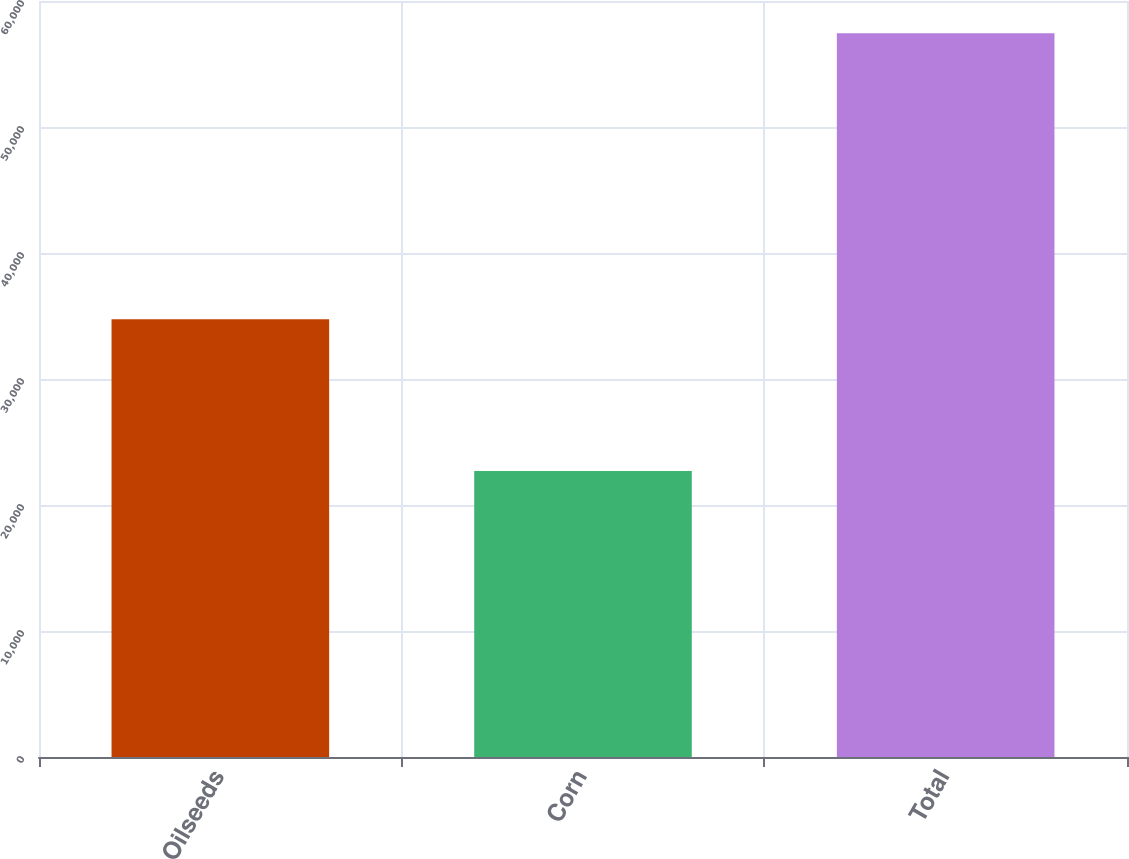<chart> <loc_0><loc_0><loc_500><loc_500><bar_chart><fcel>Oilseeds<fcel>Corn<fcel>Total<nl><fcel>34733<fcel>22700<fcel>57433<nl></chart> 